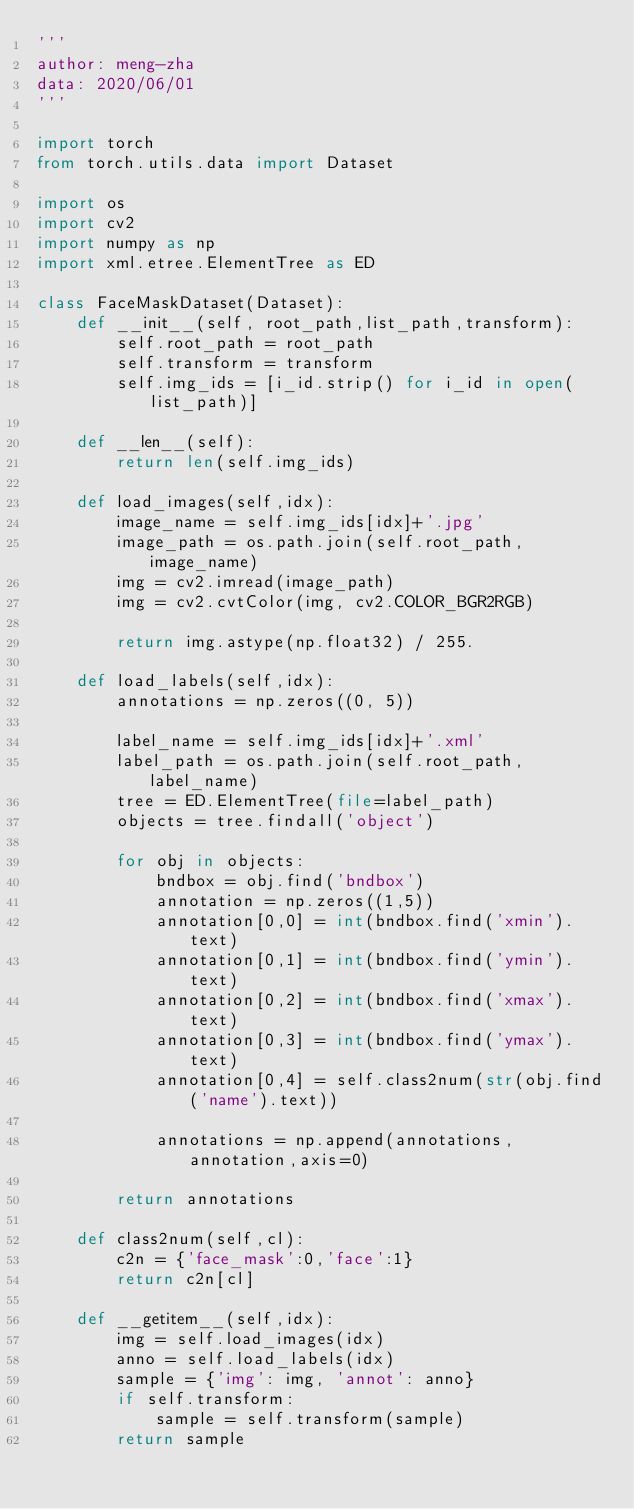Convert code to text. <code><loc_0><loc_0><loc_500><loc_500><_Python_>'''
author: meng-zha
data: 2020/06/01
'''

import torch
from torch.utils.data import Dataset

import os
import cv2
import numpy as np
import xml.etree.ElementTree as ED

class FaceMaskDataset(Dataset):
    def __init__(self, root_path,list_path,transform):
        self.root_path = root_path
        self.transform = transform
        self.img_ids = [i_id.strip() for i_id in open(list_path)]

    def __len__(self):
        return len(self.img_ids)

    def load_images(self,idx):
        image_name = self.img_ids[idx]+'.jpg'
        image_path = os.path.join(self.root_path,image_name)
        img = cv2.imread(image_path)
        img = cv2.cvtColor(img, cv2.COLOR_BGR2RGB)

        return img.astype(np.float32) / 255.

    def load_labels(self,idx):
        annotations = np.zeros((0, 5))

        label_name = self.img_ids[idx]+'.xml'
        label_path = os.path.join(self.root_path,label_name)
        tree = ED.ElementTree(file=label_path)
        objects = tree.findall('object')

        for obj in objects:
            bndbox = obj.find('bndbox')
            annotation = np.zeros((1,5))
            annotation[0,0] = int(bndbox.find('xmin').text)
            annotation[0,1] = int(bndbox.find('ymin').text)
            annotation[0,2] = int(bndbox.find('xmax').text)
            annotation[0,3] = int(bndbox.find('ymax').text)
            annotation[0,4] = self.class2num(str(obj.find('name').text))

            annotations = np.append(annotations,annotation,axis=0)

        return annotations

    def class2num(self,cl):
        c2n = {'face_mask':0,'face':1}
        return c2n[cl]

    def __getitem__(self,idx):
        img = self.load_images(idx)
        anno = self.load_labels(idx)
        sample = {'img': img, 'annot': anno}
        if self.transform:
            sample = self.transform(sample)
        return sample</code> 